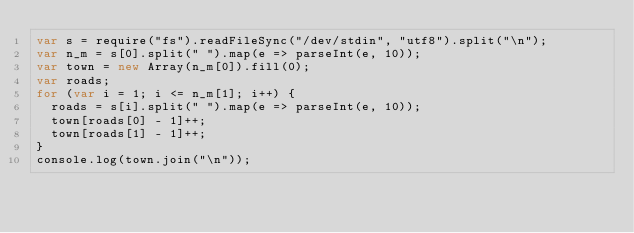Convert code to text. <code><loc_0><loc_0><loc_500><loc_500><_JavaScript_>var s = require("fs").readFileSync("/dev/stdin", "utf8").split("\n");
var n_m = s[0].split(" ").map(e => parseInt(e, 10));
var town = new Array(n_m[0]).fill(0);
var roads;
for (var i = 1; i <= n_m[1]; i++) {
  roads = s[i].split(" ").map(e => parseInt(e, 10));
  town[roads[0] - 1]++;
  town[roads[1] - 1]++;
}
console.log(town.join("\n"));</code> 